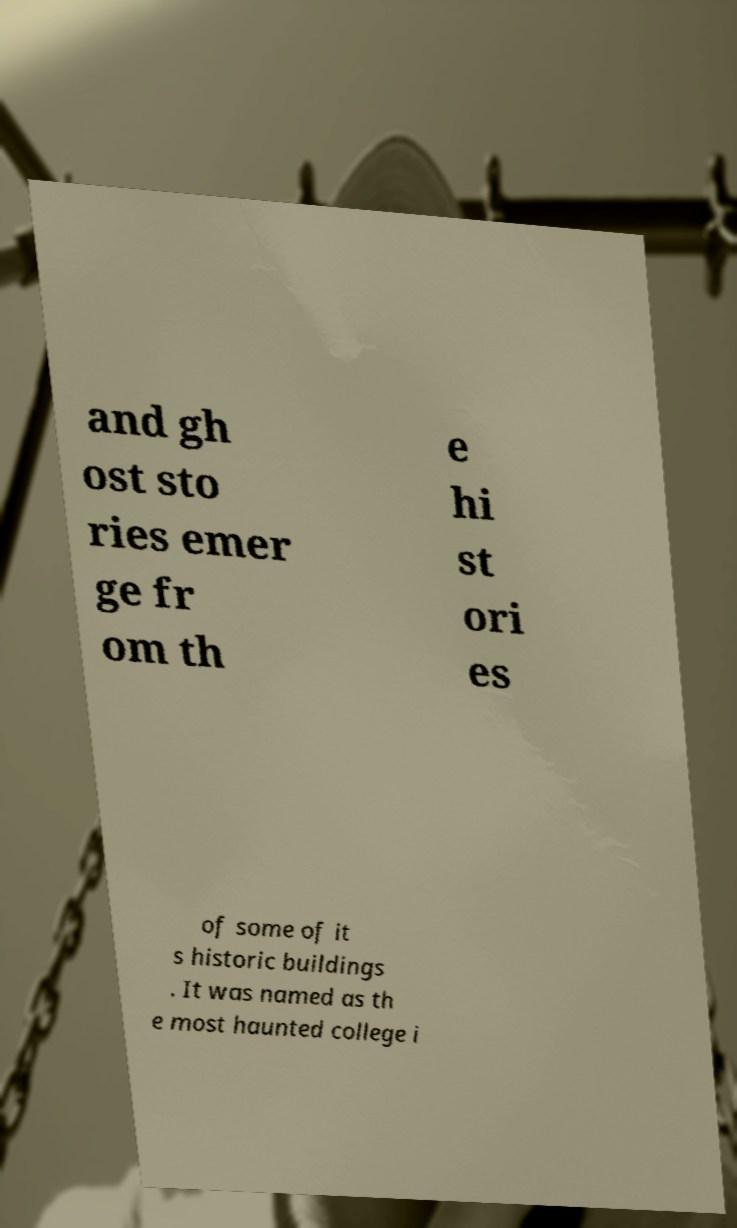Please read and relay the text visible in this image. What does it say? and gh ost sto ries emer ge fr om th e hi st ori es of some of it s historic buildings . It was named as th e most haunted college i 